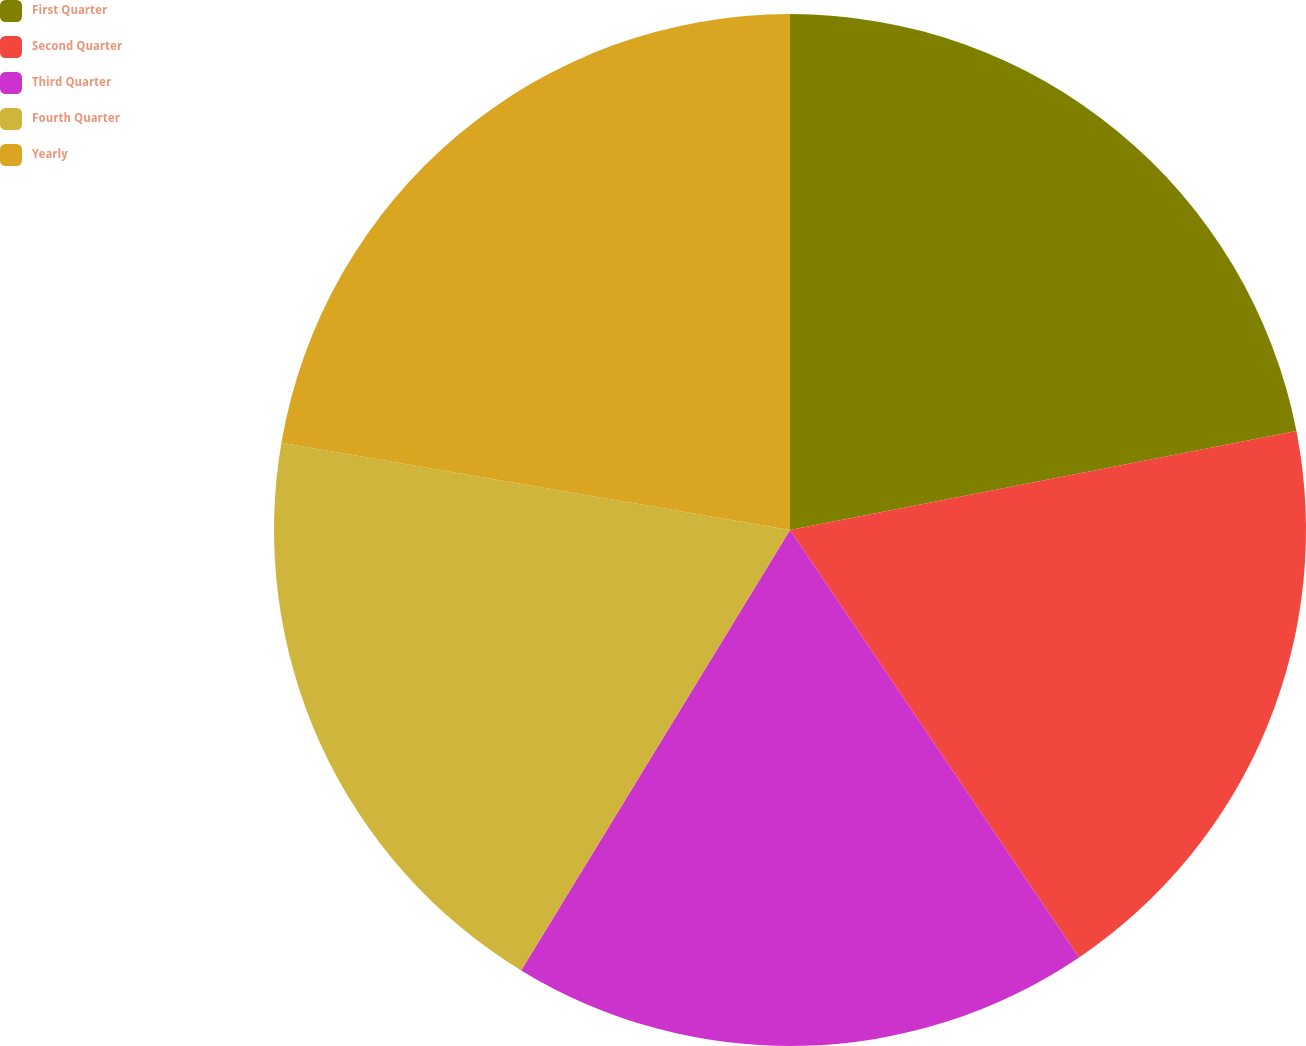Convert chart to OTSL. <chart><loc_0><loc_0><loc_500><loc_500><pie_chart><fcel>First Quarter<fcel>Second Quarter<fcel>Third Quarter<fcel>Fourth Quarter<fcel>Yearly<nl><fcel>21.93%<fcel>18.61%<fcel>18.19%<fcel>18.98%<fcel>22.3%<nl></chart> 